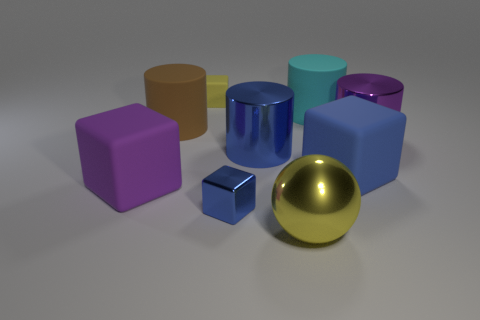The block that is the same color as the large sphere is what size?
Provide a succinct answer. Small. What material is the tiny object that is the same color as the large ball?
Provide a short and direct response. Rubber. How many metal cylinders are behind the metallic cylinder that is on the left side of the metallic cylinder right of the large yellow ball?
Offer a terse response. 1. What number of small objects are green metallic things or purple rubber blocks?
Your answer should be very brief. 0. Do the large object that is on the left side of the big brown matte cylinder and the big blue cube have the same material?
Your answer should be compact. Yes. What material is the large purple thing right of the matte cube behind the large purple thing to the right of the big purple rubber object?
Keep it short and to the point. Metal. Is there anything else that has the same size as the yellow rubber block?
Your answer should be compact. Yes. What number of shiny things are either cyan cylinders or purple spheres?
Provide a succinct answer. 0. Are there any big brown rubber cylinders?
Keep it short and to the point. Yes. There is a tiny object that is in front of the big cylinder that is on the left side of the small blue object; what color is it?
Give a very brief answer. Blue. 